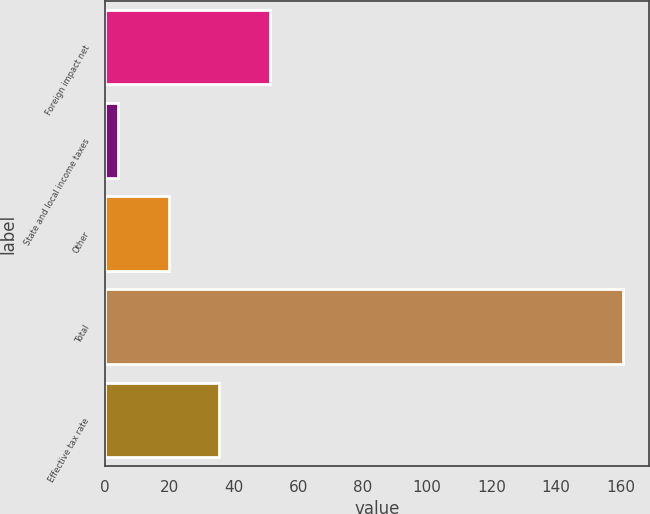<chart> <loc_0><loc_0><loc_500><loc_500><bar_chart><fcel>Foreign impact net<fcel>State and local income taxes<fcel>Other<fcel>Total<fcel>Effective tax rate<nl><fcel>51.18<fcel>4.2<fcel>19.86<fcel>160.8<fcel>35.52<nl></chart> 